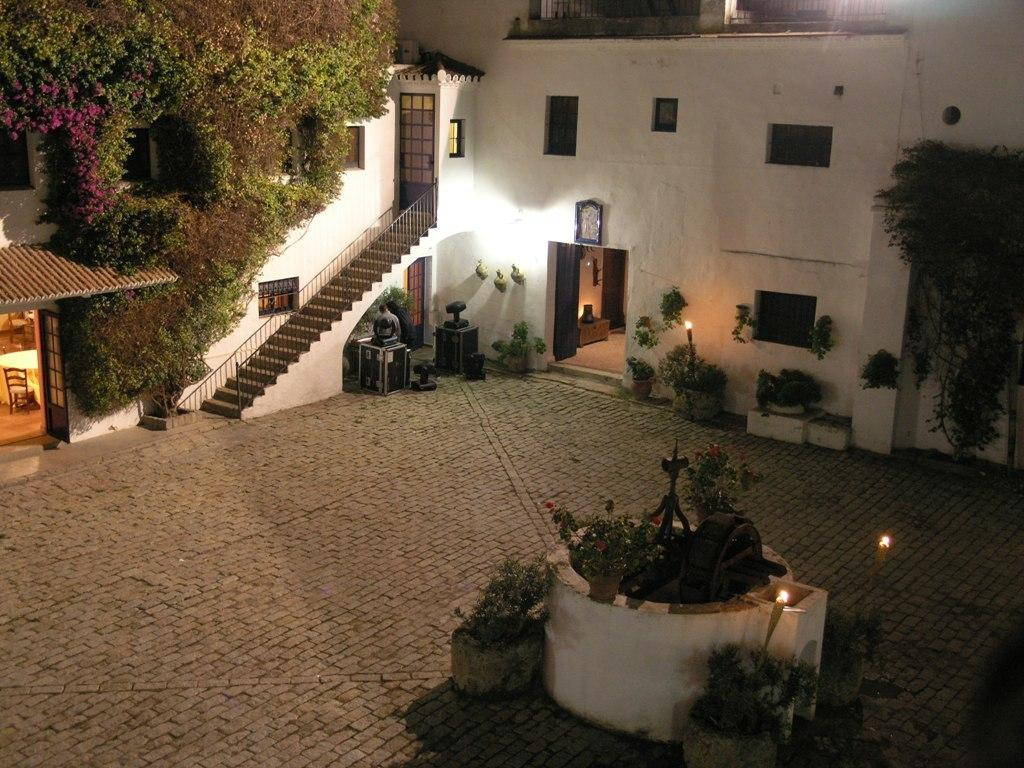What type of structure can be seen in the image? There is a building in the image. What is another object visible in the image? There is a well in the image. What type of vegetation is present in the image? There are plants and trees in the image. What architectural feature can be seen in the image? There are stairs in the image. What can be used for illumination in the image? There are lights in the image. What type of paper is being used to create a feeling of curiosity in the image? There is no paper present in the image, nor is there any indication of a feeling of curiosity. What question is being asked by the trees in the image? There are no trees asking questions in the image; trees do not have the ability to ask questions. 